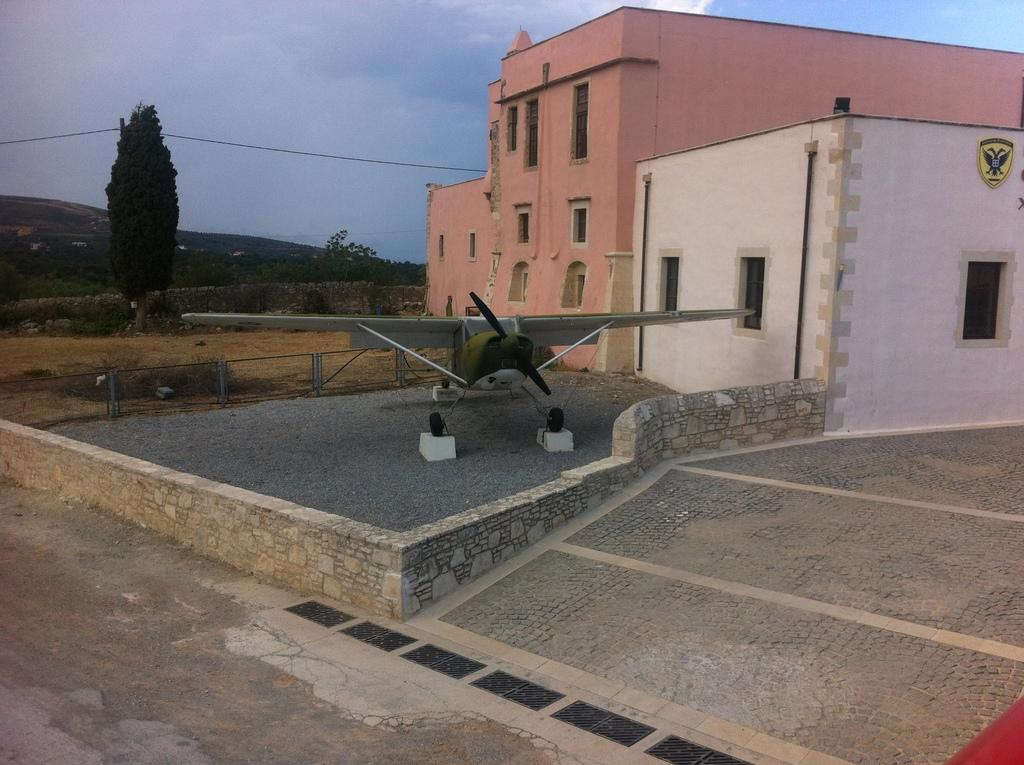What is the main subject of the image? There is an aircraft in the image. What can be seen near the aircraft? There is a fence in the image. What is located to the right of the image? There are buildings to the right of the image. What type of natural features can be seen in the background of the image? There are trees, mountains, and the sky visible in the background of the image. What type of fork can be seen in the image? There is no fork present in the image. How does the aircraft turn in the image? The aircraft does not turn in the image; it is stationary. 